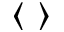<formula> <loc_0><loc_0><loc_500><loc_500>\langle \rangle</formula> 